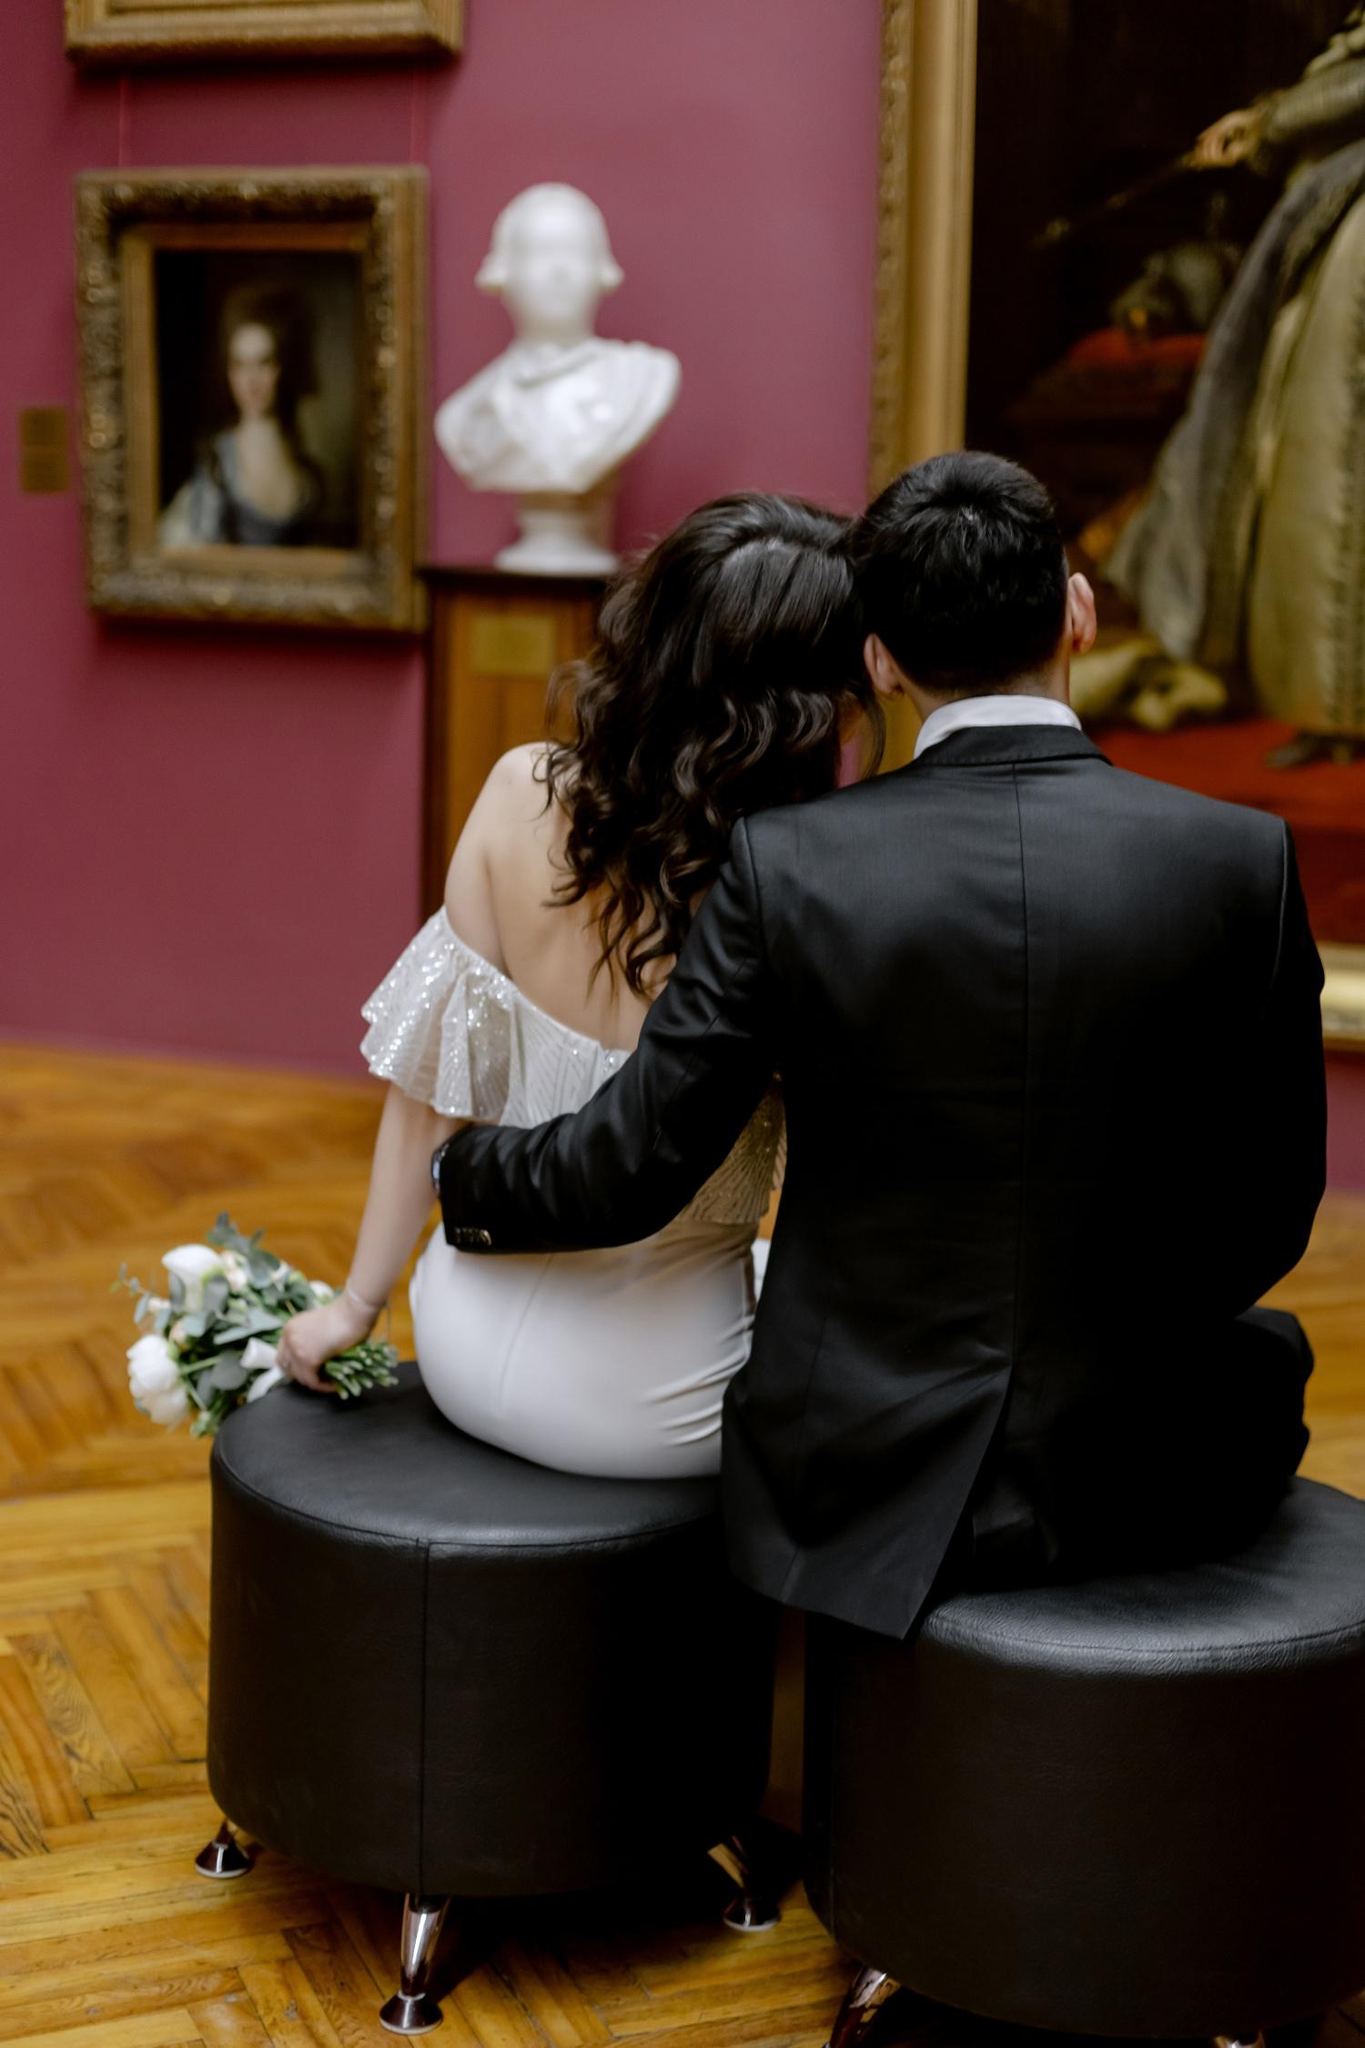What might the choice of flowers indicate about the occasion? The bouquet of white flowers held by the woman, likely peonies or roses, are traditionally associated with weddings and symbolize beauty, love, and honor. Their pristine color complements the woman's dress, reinforcing the idea of a marriage celebration. These flowers could indicate their special day, underlining its significance with classic and elegant choices that resonate with the timeless appeal of their surroundings. Is there a specific reason they might choose this gallery for such an event? Choosing this gallery for a wedding or a significant celebration could be motivated by a personal connection to art or a desire for a distinctive, memorable location. Art galleries, with their serene and inspiring atmosphere, offer a unique backdrop that highlights the couple's interests and personal tastes. This particular gallery, with its rich colors and classic artworks, provides a setting that is both visually stunning and steeply imbued with cultural history, making it a fitting venue for significant life events. 